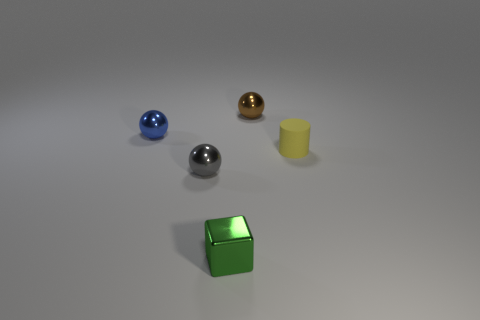There is a metal ball that is in front of the small object that is right of the tiny metallic sphere behind the blue ball; what size is it?
Provide a succinct answer. Small. How many other objects are there of the same shape as the small gray object?
Your answer should be compact. 2. There is a thing to the right of the small brown metallic thing; does it have the same color as the tiny metallic ball that is in front of the yellow thing?
Give a very brief answer. No. There is a matte cylinder that is the same size as the shiny block; what color is it?
Offer a terse response. Yellow. Is there a tiny metal thing of the same color as the cylinder?
Make the answer very short. No. There is a ball that is to the right of the gray metallic object; is it the same size as the green shiny thing?
Your response must be concise. Yes. Are there the same number of small things that are right of the yellow object and large gray rubber balls?
Provide a short and direct response. Yes. What number of things are either shiny spheres on the left side of the tiny brown shiny sphere or yellow matte things?
Your response must be concise. 3. There is a small thing that is on the right side of the gray object and behind the matte cylinder; what is its shape?
Make the answer very short. Sphere. How many things are tiny gray metal balls in front of the tiny blue object or metallic things that are left of the brown ball?
Ensure brevity in your answer.  3. 